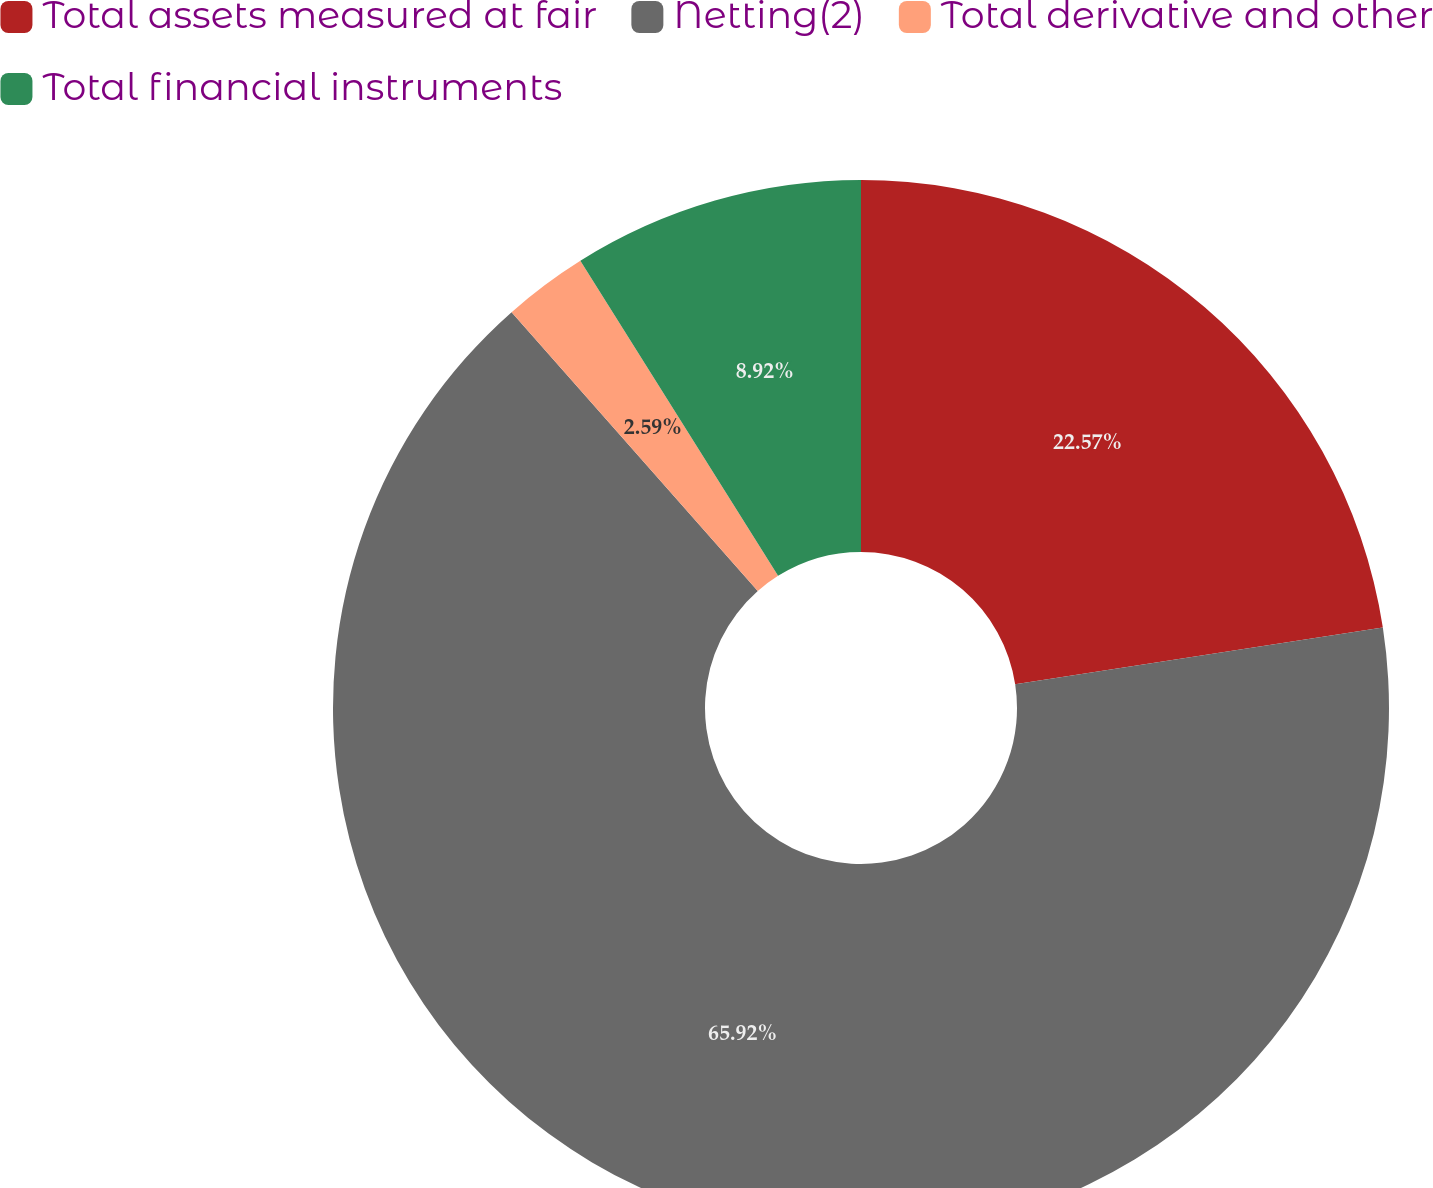Convert chart. <chart><loc_0><loc_0><loc_500><loc_500><pie_chart><fcel>Total assets measured at fair<fcel>Netting(2)<fcel>Total derivative and other<fcel>Total financial instruments<nl><fcel>22.57%<fcel>65.93%<fcel>2.59%<fcel>8.92%<nl></chart> 